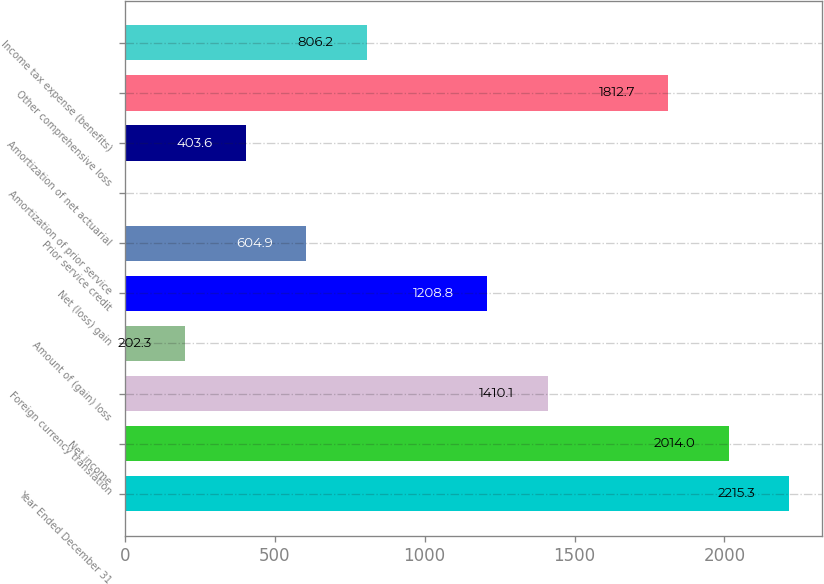<chart> <loc_0><loc_0><loc_500><loc_500><bar_chart><fcel>Year Ended December 31<fcel>Net income<fcel>Foreign currency translation<fcel>Amount of (gain) loss<fcel>Net (loss) gain<fcel>Prior service credit<fcel>Amortization of prior service<fcel>Amortization of net actuarial<fcel>Other comprehensive loss<fcel>Income tax expense (benefits)<nl><fcel>2215.3<fcel>2014<fcel>1410.1<fcel>202.3<fcel>1208.8<fcel>604.9<fcel>1<fcel>403.6<fcel>1812.7<fcel>806.2<nl></chart> 